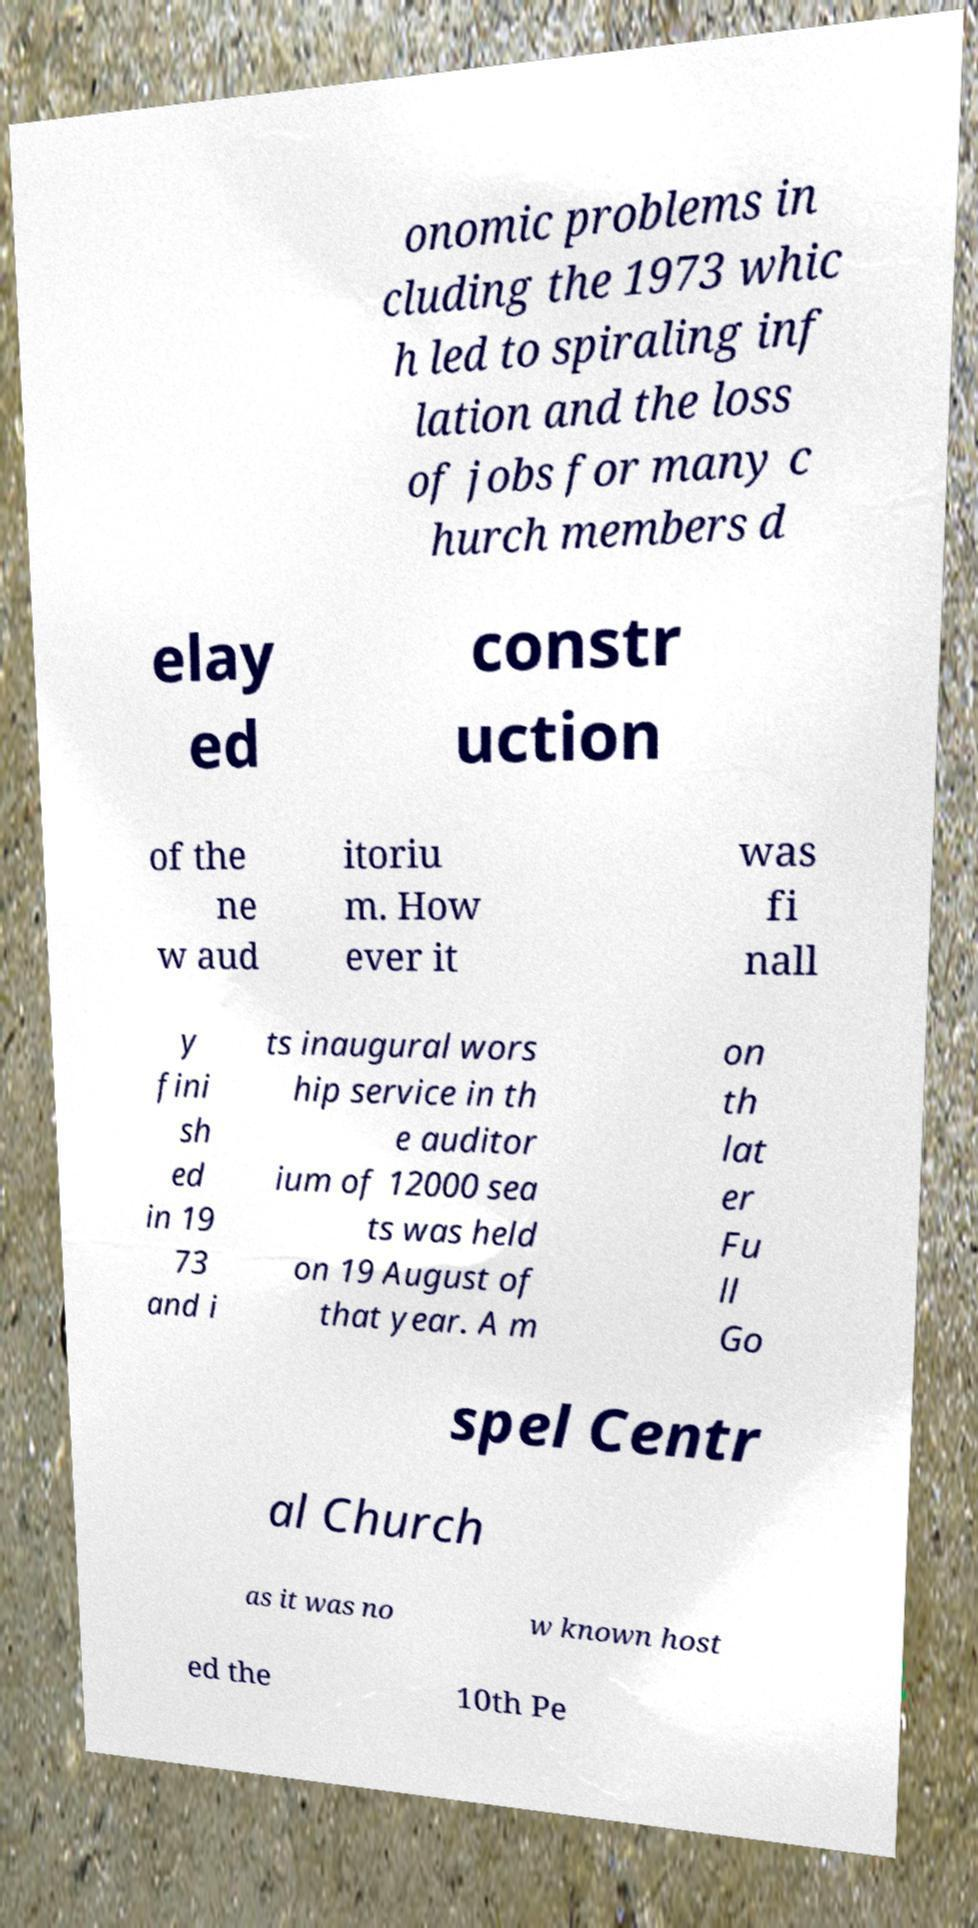For documentation purposes, I need the text within this image transcribed. Could you provide that? onomic problems in cluding the 1973 whic h led to spiraling inf lation and the loss of jobs for many c hurch members d elay ed constr uction of the ne w aud itoriu m. How ever it was fi nall y fini sh ed in 19 73 and i ts inaugural wors hip service in th e auditor ium of 12000 sea ts was held on 19 August of that year. A m on th lat er Fu ll Go spel Centr al Church as it was no w known host ed the 10th Pe 